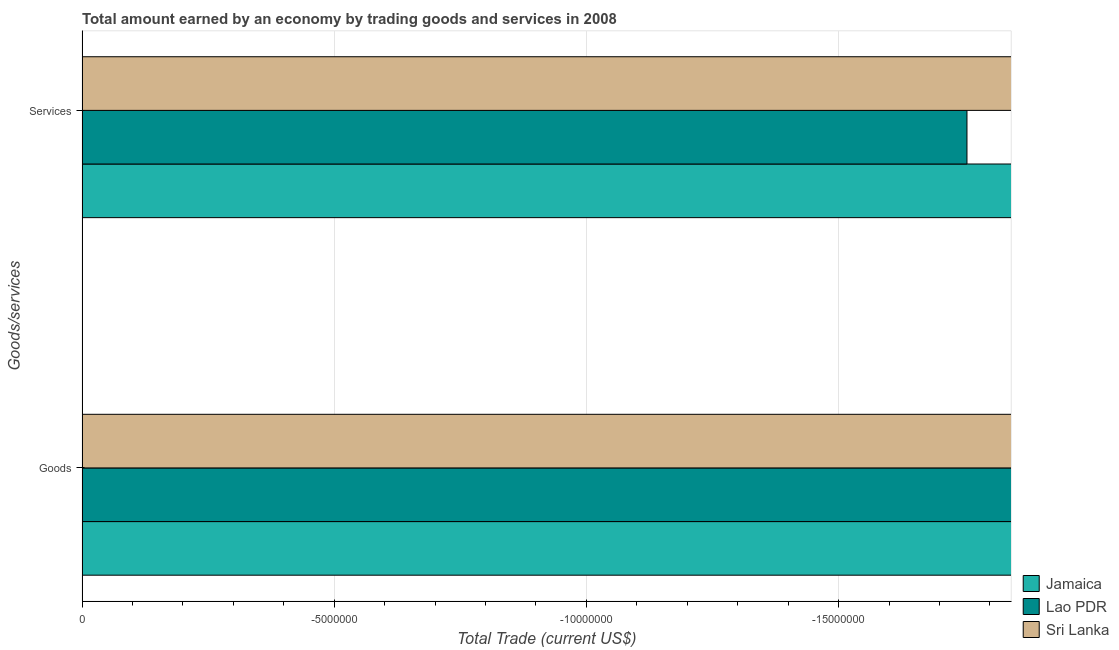Are the number of bars per tick equal to the number of legend labels?
Offer a terse response. No. What is the label of the 1st group of bars from the top?
Make the answer very short. Services. Across all countries, what is the minimum amount earned by trading services?
Your answer should be very brief. 0. What is the total amount earned by trading services in the graph?
Provide a succinct answer. 0. In how many countries, is the amount earned by trading goods greater than the average amount earned by trading goods taken over all countries?
Offer a very short reply. 0. How many bars are there?
Provide a short and direct response. 0. Are all the bars in the graph horizontal?
Your answer should be compact. Yes. Does the graph contain any zero values?
Your answer should be very brief. Yes. Does the graph contain grids?
Your answer should be compact. Yes. What is the title of the graph?
Offer a very short reply. Total amount earned by an economy by trading goods and services in 2008. Does "East Asia (all income levels)" appear as one of the legend labels in the graph?
Provide a short and direct response. No. What is the label or title of the X-axis?
Your response must be concise. Total Trade (current US$). What is the label or title of the Y-axis?
Provide a succinct answer. Goods/services. What is the Total Trade (current US$) in Lao PDR in Goods?
Your response must be concise. 0. What is the Total Trade (current US$) in Sri Lanka in Goods?
Ensure brevity in your answer.  0. What is the Total Trade (current US$) of Sri Lanka in Services?
Your answer should be very brief. 0. What is the total Total Trade (current US$) in Lao PDR in the graph?
Keep it short and to the point. 0. What is the total Total Trade (current US$) of Sri Lanka in the graph?
Your answer should be compact. 0. 